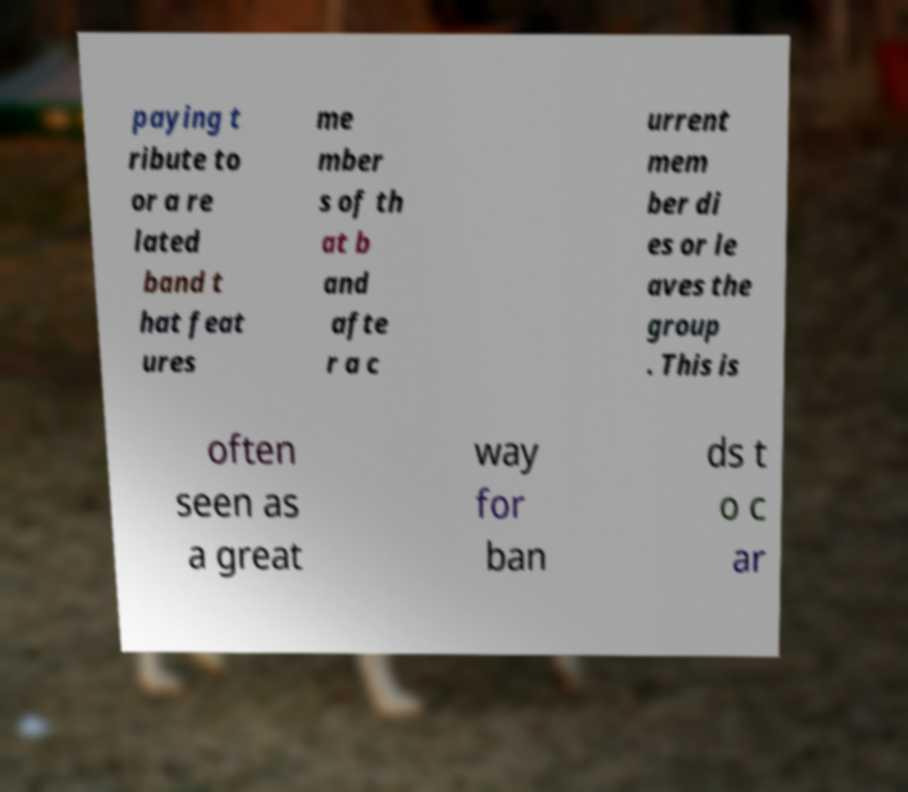Please identify and transcribe the text found in this image. paying t ribute to or a re lated band t hat feat ures me mber s of th at b and afte r a c urrent mem ber di es or le aves the group . This is often seen as a great way for ban ds t o c ar 